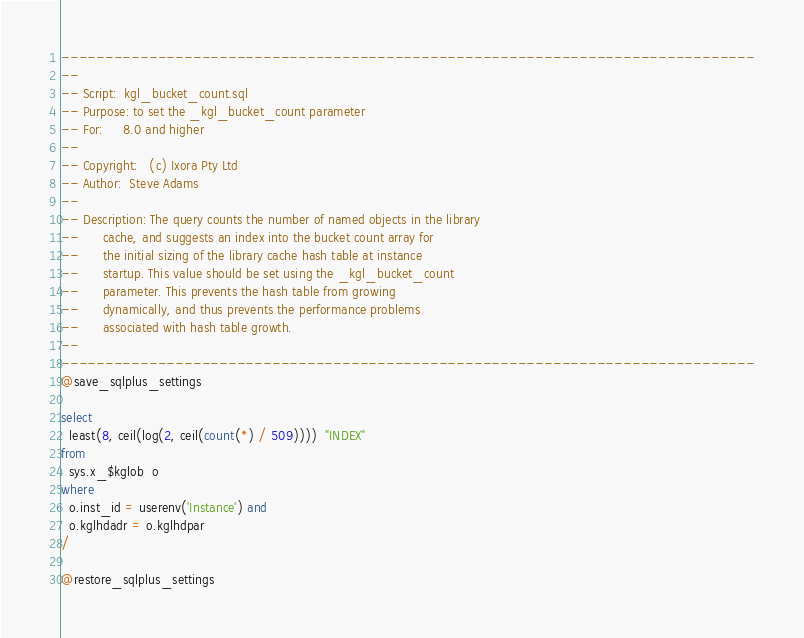<code> <loc_0><loc_0><loc_500><loc_500><_SQL_>-------------------------------------------------------------------------------
--
-- Script:	kgl_bucket_count.sql
-- Purpose:	to set the _kgl_bucket_count parameter
-- For:		8.0 and higher
--
-- Copyright:	(c) Ixora Pty Ltd
-- Author:	Steve Adams
--
-- Description:	The query counts the number of named objects in the library
--		cache, and suggests an index into the bucket count array for
--		the initial sizing of the library cache hash table at instance
--		startup. This value should be set using the _kgl_bucket_count
--		parameter. This prevents the hash table from growing
--		dynamically, and thus prevents the performance problems
--		associated with hash table growth.
--
-------------------------------------------------------------------------------
@save_sqlplus_settings

select
  least(8, ceil(log(2, ceil(count(*) / 509))))  "INDEX"
from
  sys.x_$kglob  o
where
  o.inst_id = userenv('Instance') and
  o.kglhdadr = o.kglhdpar
/

@restore_sqlplus_settings
</code> 